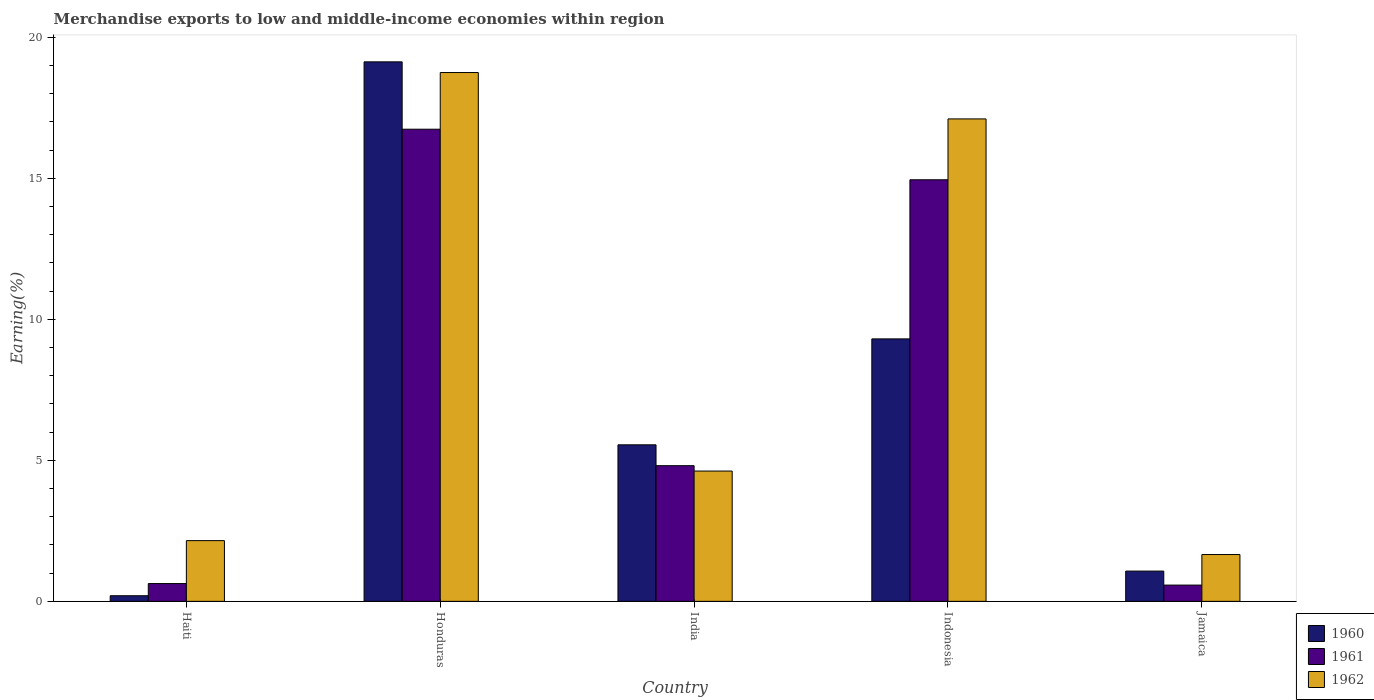Are the number of bars per tick equal to the number of legend labels?
Your answer should be compact. Yes. How many bars are there on the 4th tick from the left?
Offer a very short reply. 3. How many bars are there on the 1st tick from the right?
Ensure brevity in your answer.  3. What is the label of the 4th group of bars from the left?
Provide a succinct answer. Indonesia. What is the percentage of amount earned from merchandise exports in 1961 in Jamaica?
Your response must be concise. 0.58. Across all countries, what is the maximum percentage of amount earned from merchandise exports in 1961?
Provide a succinct answer. 16.74. Across all countries, what is the minimum percentage of amount earned from merchandise exports in 1960?
Your response must be concise. 0.2. In which country was the percentage of amount earned from merchandise exports in 1962 maximum?
Provide a short and direct response. Honduras. In which country was the percentage of amount earned from merchandise exports in 1960 minimum?
Offer a terse response. Haiti. What is the total percentage of amount earned from merchandise exports in 1962 in the graph?
Offer a terse response. 44.29. What is the difference between the percentage of amount earned from merchandise exports in 1960 in Haiti and that in Jamaica?
Provide a short and direct response. -0.87. What is the difference between the percentage of amount earned from merchandise exports in 1962 in Haiti and the percentage of amount earned from merchandise exports in 1960 in India?
Your answer should be very brief. -3.4. What is the average percentage of amount earned from merchandise exports in 1960 per country?
Your response must be concise. 7.05. What is the difference between the percentage of amount earned from merchandise exports of/in 1961 and percentage of amount earned from merchandise exports of/in 1962 in India?
Ensure brevity in your answer.  0.19. In how many countries, is the percentage of amount earned from merchandise exports in 1962 greater than 3 %?
Give a very brief answer. 3. What is the ratio of the percentage of amount earned from merchandise exports in 1960 in Haiti to that in Honduras?
Offer a very short reply. 0.01. Is the percentage of amount earned from merchandise exports in 1961 in India less than that in Jamaica?
Your answer should be very brief. No. What is the difference between the highest and the second highest percentage of amount earned from merchandise exports in 1961?
Provide a succinct answer. 11.93. What is the difference between the highest and the lowest percentage of amount earned from merchandise exports in 1960?
Make the answer very short. 18.93. Is the sum of the percentage of amount earned from merchandise exports in 1962 in Haiti and Jamaica greater than the maximum percentage of amount earned from merchandise exports in 1960 across all countries?
Your answer should be compact. No. What does the 2nd bar from the left in Honduras represents?
Give a very brief answer. 1961. Is it the case that in every country, the sum of the percentage of amount earned from merchandise exports in 1961 and percentage of amount earned from merchandise exports in 1960 is greater than the percentage of amount earned from merchandise exports in 1962?
Your answer should be compact. No. How many bars are there?
Give a very brief answer. 15. Are all the bars in the graph horizontal?
Provide a short and direct response. No. What is the difference between two consecutive major ticks on the Y-axis?
Your answer should be very brief. 5. Does the graph contain any zero values?
Provide a succinct answer. No. Does the graph contain grids?
Give a very brief answer. No. Where does the legend appear in the graph?
Offer a very short reply. Bottom right. How are the legend labels stacked?
Provide a succinct answer. Vertical. What is the title of the graph?
Keep it short and to the point. Merchandise exports to low and middle-income economies within region. What is the label or title of the X-axis?
Provide a succinct answer. Country. What is the label or title of the Y-axis?
Give a very brief answer. Earning(%). What is the Earning(%) of 1960 in Haiti?
Keep it short and to the point. 0.2. What is the Earning(%) of 1961 in Haiti?
Provide a short and direct response. 0.63. What is the Earning(%) in 1962 in Haiti?
Keep it short and to the point. 2.15. What is the Earning(%) of 1960 in Honduras?
Your response must be concise. 19.13. What is the Earning(%) of 1961 in Honduras?
Give a very brief answer. 16.74. What is the Earning(%) in 1962 in Honduras?
Your response must be concise. 18.75. What is the Earning(%) of 1960 in India?
Provide a succinct answer. 5.55. What is the Earning(%) of 1961 in India?
Give a very brief answer. 4.81. What is the Earning(%) in 1962 in India?
Offer a terse response. 4.62. What is the Earning(%) in 1960 in Indonesia?
Keep it short and to the point. 9.31. What is the Earning(%) of 1961 in Indonesia?
Ensure brevity in your answer.  14.95. What is the Earning(%) in 1962 in Indonesia?
Keep it short and to the point. 17.11. What is the Earning(%) in 1960 in Jamaica?
Offer a very short reply. 1.07. What is the Earning(%) of 1961 in Jamaica?
Your answer should be very brief. 0.58. What is the Earning(%) in 1962 in Jamaica?
Make the answer very short. 1.66. Across all countries, what is the maximum Earning(%) of 1960?
Offer a terse response. 19.13. Across all countries, what is the maximum Earning(%) of 1961?
Your response must be concise. 16.74. Across all countries, what is the maximum Earning(%) of 1962?
Provide a succinct answer. 18.75. Across all countries, what is the minimum Earning(%) of 1960?
Your answer should be very brief. 0.2. Across all countries, what is the minimum Earning(%) of 1961?
Make the answer very short. 0.58. Across all countries, what is the minimum Earning(%) in 1962?
Offer a very short reply. 1.66. What is the total Earning(%) of 1960 in the graph?
Keep it short and to the point. 35.26. What is the total Earning(%) of 1961 in the graph?
Give a very brief answer. 37.71. What is the total Earning(%) of 1962 in the graph?
Your answer should be very brief. 44.29. What is the difference between the Earning(%) of 1960 in Haiti and that in Honduras?
Give a very brief answer. -18.93. What is the difference between the Earning(%) in 1961 in Haiti and that in Honduras?
Ensure brevity in your answer.  -16.11. What is the difference between the Earning(%) of 1962 in Haiti and that in Honduras?
Your response must be concise. -16.6. What is the difference between the Earning(%) in 1960 in Haiti and that in India?
Offer a very short reply. -5.35. What is the difference between the Earning(%) of 1961 in Haiti and that in India?
Your answer should be very brief. -4.18. What is the difference between the Earning(%) of 1962 in Haiti and that in India?
Offer a very short reply. -2.47. What is the difference between the Earning(%) in 1960 in Haiti and that in Indonesia?
Offer a very short reply. -9.11. What is the difference between the Earning(%) of 1961 in Haiti and that in Indonesia?
Ensure brevity in your answer.  -14.32. What is the difference between the Earning(%) of 1962 in Haiti and that in Indonesia?
Provide a succinct answer. -14.95. What is the difference between the Earning(%) of 1960 in Haiti and that in Jamaica?
Offer a very short reply. -0.87. What is the difference between the Earning(%) in 1961 in Haiti and that in Jamaica?
Your answer should be compact. 0.05. What is the difference between the Earning(%) in 1962 in Haiti and that in Jamaica?
Keep it short and to the point. 0.49. What is the difference between the Earning(%) of 1960 in Honduras and that in India?
Provide a short and direct response. 13.58. What is the difference between the Earning(%) in 1961 in Honduras and that in India?
Your answer should be compact. 11.93. What is the difference between the Earning(%) in 1962 in Honduras and that in India?
Ensure brevity in your answer.  14.13. What is the difference between the Earning(%) in 1960 in Honduras and that in Indonesia?
Provide a short and direct response. 9.82. What is the difference between the Earning(%) of 1961 in Honduras and that in Indonesia?
Offer a terse response. 1.79. What is the difference between the Earning(%) in 1962 in Honduras and that in Indonesia?
Your answer should be very brief. 1.64. What is the difference between the Earning(%) of 1960 in Honduras and that in Jamaica?
Offer a terse response. 18.06. What is the difference between the Earning(%) in 1961 in Honduras and that in Jamaica?
Keep it short and to the point. 16.16. What is the difference between the Earning(%) in 1962 in Honduras and that in Jamaica?
Keep it short and to the point. 17.09. What is the difference between the Earning(%) in 1960 in India and that in Indonesia?
Offer a terse response. -3.76. What is the difference between the Earning(%) of 1961 in India and that in Indonesia?
Your answer should be very brief. -10.14. What is the difference between the Earning(%) of 1962 in India and that in Indonesia?
Offer a very short reply. -12.49. What is the difference between the Earning(%) of 1960 in India and that in Jamaica?
Provide a short and direct response. 4.48. What is the difference between the Earning(%) of 1961 in India and that in Jamaica?
Make the answer very short. 4.23. What is the difference between the Earning(%) of 1962 in India and that in Jamaica?
Offer a terse response. 2.96. What is the difference between the Earning(%) of 1960 in Indonesia and that in Jamaica?
Keep it short and to the point. 8.23. What is the difference between the Earning(%) of 1961 in Indonesia and that in Jamaica?
Offer a terse response. 14.37. What is the difference between the Earning(%) of 1962 in Indonesia and that in Jamaica?
Ensure brevity in your answer.  15.45. What is the difference between the Earning(%) in 1960 in Haiti and the Earning(%) in 1961 in Honduras?
Provide a short and direct response. -16.54. What is the difference between the Earning(%) in 1960 in Haiti and the Earning(%) in 1962 in Honduras?
Make the answer very short. -18.55. What is the difference between the Earning(%) in 1961 in Haiti and the Earning(%) in 1962 in Honduras?
Keep it short and to the point. -18.12. What is the difference between the Earning(%) of 1960 in Haiti and the Earning(%) of 1961 in India?
Your answer should be very brief. -4.61. What is the difference between the Earning(%) of 1960 in Haiti and the Earning(%) of 1962 in India?
Provide a succinct answer. -4.42. What is the difference between the Earning(%) in 1961 in Haiti and the Earning(%) in 1962 in India?
Provide a succinct answer. -3.99. What is the difference between the Earning(%) of 1960 in Haiti and the Earning(%) of 1961 in Indonesia?
Offer a terse response. -14.75. What is the difference between the Earning(%) in 1960 in Haiti and the Earning(%) in 1962 in Indonesia?
Make the answer very short. -16.91. What is the difference between the Earning(%) in 1961 in Haiti and the Earning(%) in 1962 in Indonesia?
Make the answer very short. -16.47. What is the difference between the Earning(%) in 1960 in Haiti and the Earning(%) in 1961 in Jamaica?
Your answer should be very brief. -0.38. What is the difference between the Earning(%) in 1960 in Haiti and the Earning(%) in 1962 in Jamaica?
Your response must be concise. -1.46. What is the difference between the Earning(%) of 1961 in Haiti and the Earning(%) of 1962 in Jamaica?
Offer a terse response. -1.03. What is the difference between the Earning(%) in 1960 in Honduras and the Earning(%) in 1961 in India?
Provide a succinct answer. 14.32. What is the difference between the Earning(%) of 1960 in Honduras and the Earning(%) of 1962 in India?
Make the answer very short. 14.51. What is the difference between the Earning(%) in 1961 in Honduras and the Earning(%) in 1962 in India?
Keep it short and to the point. 12.12. What is the difference between the Earning(%) in 1960 in Honduras and the Earning(%) in 1961 in Indonesia?
Ensure brevity in your answer.  4.18. What is the difference between the Earning(%) in 1960 in Honduras and the Earning(%) in 1962 in Indonesia?
Provide a short and direct response. 2.02. What is the difference between the Earning(%) in 1961 in Honduras and the Earning(%) in 1962 in Indonesia?
Offer a terse response. -0.37. What is the difference between the Earning(%) of 1960 in Honduras and the Earning(%) of 1961 in Jamaica?
Your answer should be very brief. 18.55. What is the difference between the Earning(%) of 1960 in Honduras and the Earning(%) of 1962 in Jamaica?
Give a very brief answer. 17.47. What is the difference between the Earning(%) in 1961 in Honduras and the Earning(%) in 1962 in Jamaica?
Provide a succinct answer. 15.08. What is the difference between the Earning(%) of 1960 in India and the Earning(%) of 1961 in Indonesia?
Give a very brief answer. -9.4. What is the difference between the Earning(%) of 1960 in India and the Earning(%) of 1962 in Indonesia?
Ensure brevity in your answer.  -11.56. What is the difference between the Earning(%) in 1961 in India and the Earning(%) in 1962 in Indonesia?
Your response must be concise. -12.3. What is the difference between the Earning(%) in 1960 in India and the Earning(%) in 1961 in Jamaica?
Your answer should be very brief. 4.97. What is the difference between the Earning(%) in 1960 in India and the Earning(%) in 1962 in Jamaica?
Your answer should be very brief. 3.89. What is the difference between the Earning(%) of 1961 in India and the Earning(%) of 1962 in Jamaica?
Provide a succinct answer. 3.15. What is the difference between the Earning(%) of 1960 in Indonesia and the Earning(%) of 1961 in Jamaica?
Provide a short and direct response. 8.73. What is the difference between the Earning(%) in 1960 in Indonesia and the Earning(%) in 1962 in Jamaica?
Your response must be concise. 7.65. What is the difference between the Earning(%) of 1961 in Indonesia and the Earning(%) of 1962 in Jamaica?
Provide a succinct answer. 13.29. What is the average Earning(%) in 1960 per country?
Offer a very short reply. 7.05. What is the average Earning(%) in 1961 per country?
Your response must be concise. 7.54. What is the average Earning(%) in 1962 per country?
Provide a succinct answer. 8.86. What is the difference between the Earning(%) of 1960 and Earning(%) of 1961 in Haiti?
Provide a short and direct response. -0.43. What is the difference between the Earning(%) of 1960 and Earning(%) of 1962 in Haiti?
Your answer should be compact. -1.95. What is the difference between the Earning(%) in 1961 and Earning(%) in 1962 in Haiti?
Your response must be concise. -1.52. What is the difference between the Earning(%) of 1960 and Earning(%) of 1961 in Honduras?
Offer a terse response. 2.39. What is the difference between the Earning(%) of 1960 and Earning(%) of 1962 in Honduras?
Provide a succinct answer. 0.38. What is the difference between the Earning(%) in 1961 and Earning(%) in 1962 in Honduras?
Offer a terse response. -2.01. What is the difference between the Earning(%) of 1960 and Earning(%) of 1961 in India?
Your answer should be very brief. 0.74. What is the difference between the Earning(%) in 1960 and Earning(%) in 1962 in India?
Make the answer very short. 0.93. What is the difference between the Earning(%) in 1961 and Earning(%) in 1962 in India?
Make the answer very short. 0.19. What is the difference between the Earning(%) of 1960 and Earning(%) of 1961 in Indonesia?
Your answer should be very brief. -5.64. What is the difference between the Earning(%) in 1960 and Earning(%) in 1962 in Indonesia?
Provide a short and direct response. -7.8. What is the difference between the Earning(%) in 1961 and Earning(%) in 1962 in Indonesia?
Your answer should be very brief. -2.16. What is the difference between the Earning(%) of 1960 and Earning(%) of 1961 in Jamaica?
Offer a very short reply. 0.5. What is the difference between the Earning(%) of 1960 and Earning(%) of 1962 in Jamaica?
Keep it short and to the point. -0.59. What is the difference between the Earning(%) in 1961 and Earning(%) in 1962 in Jamaica?
Provide a short and direct response. -1.08. What is the ratio of the Earning(%) of 1960 in Haiti to that in Honduras?
Provide a short and direct response. 0.01. What is the ratio of the Earning(%) of 1961 in Haiti to that in Honduras?
Your answer should be compact. 0.04. What is the ratio of the Earning(%) in 1962 in Haiti to that in Honduras?
Offer a terse response. 0.11. What is the ratio of the Earning(%) in 1960 in Haiti to that in India?
Provide a short and direct response. 0.04. What is the ratio of the Earning(%) in 1961 in Haiti to that in India?
Your answer should be very brief. 0.13. What is the ratio of the Earning(%) in 1962 in Haiti to that in India?
Your answer should be compact. 0.47. What is the ratio of the Earning(%) in 1960 in Haiti to that in Indonesia?
Your answer should be very brief. 0.02. What is the ratio of the Earning(%) of 1961 in Haiti to that in Indonesia?
Provide a succinct answer. 0.04. What is the ratio of the Earning(%) of 1962 in Haiti to that in Indonesia?
Provide a short and direct response. 0.13. What is the ratio of the Earning(%) in 1960 in Haiti to that in Jamaica?
Provide a short and direct response. 0.19. What is the ratio of the Earning(%) of 1961 in Haiti to that in Jamaica?
Provide a succinct answer. 1.09. What is the ratio of the Earning(%) in 1962 in Haiti to that in Jamaica?
Your answer should be compact. 1.3. What is the ratio of the Earning(%) of 1960 in Honduras to that in India?
Ensure brevity in your answer.  3.45. What is the ratio of the Earning(%) of 1961 in Honduras to that in India?
Provide a succinct answer. 3.48. What is the ratio of the Earning(%) of 1962 in Honduras to that in India?
Give a very brief answer. 4.06. What is the ratio of the Earning(%) of 1960 in Honduras to that in Indonesia?
Ensure brevity in your answer.  2.06. What is the ratio of the Earning(%) in 1961 in Honduras to that in Indonesia?
Make the answer very short. 1.12. What is the ratio of the Earning(%) in 1962 in Honduras to that in Indonesia?
Offer a very short reply. 1.1. What is the ratio of the Earning(%) in 1960 in Honduras to that in Jamaica?
Provide a succinct answer. 17.82. What is the ratio of the Earning(%) in 1961 in Honduras to that in Jamaica?
Provide a short and direct response. 29.01. What is the ratio of the Earning(%) in 1962 in Honduras to that in Jamaica?
Give a very brief answer. 11.29. What is the ratio of the Earning(%) of 1960 in India to that in Indonesia?
Offer a terse response. 0.6. What is the ratio of the Earning(%) in 1961 in India to that in Indonesia?
Your answer should be very brief. 0.32. What is the ratio of the Earning(%) in 1962 in India to that in Indonesia?
Give a very brief answer. 0.27. What is the ratio of the Earning(%) of 1960 in India to that in Jamaica?
Ensure brevity in your answer.  5.17. What is the ratio of the Earning(%) in 1961 in India to that in Jamaica?
Provide a succinct answer. 8.34. What is the ratio of the Earning(%) in 1962 in India to that in Jamaica?
Offer a very short reply. 2.78. What is the ratio of the Earning(%) of 1960 in Indonesia to that in Jamaica?
Provide a succinct answer. 8.67. What is the ratio of the Earning(%) in 1961 in Indonesia to that in Jamaica?
Provide a succinct answer. 25.91. What is the ratio of the Earning(%) of 1962 in Indonesia to that in Jamaica?
Ensure brevity in your answer.  10.3. What is the difference between the highest and the second highest Earning(%) of 1960?
Your answer should be compact. 9.82. What is the difference between the highest and the second highest Earning(%) of 1961?
Keep it short and to the point. 1.79. What is the difference between the highest and the second highest Earning(%) of 1962?
Offer a terse response. 1.64. What is the difference between the highest and the lowest Earning(%) of 1960?
Keep it short and to the point. 18.93. What is the difference between the highest and the lowest Earning(%) of 1961?
Ensure brevity in your answer.  16.16. What is the difference between the highest and the lowest Earning(%) of 1962?
Provide a short and direct response. 17.09. 